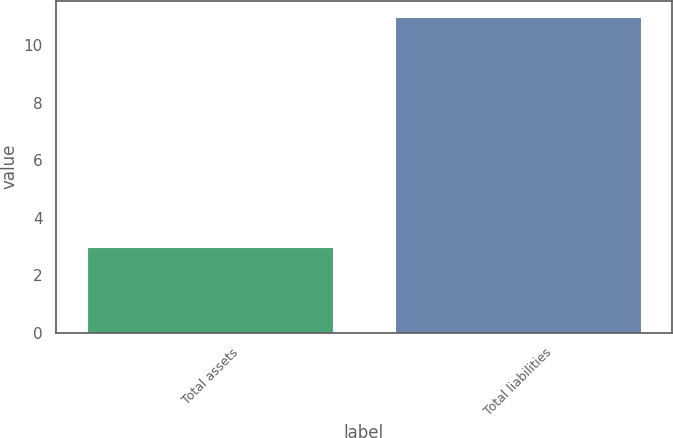Convert chart. <chart><loc_0><loc_0><loc_500><loc_500><bar_chart><fcel>Total assets<fcel>Total liabilities<nl><fcel>3<fcel>11<nl></chart> 